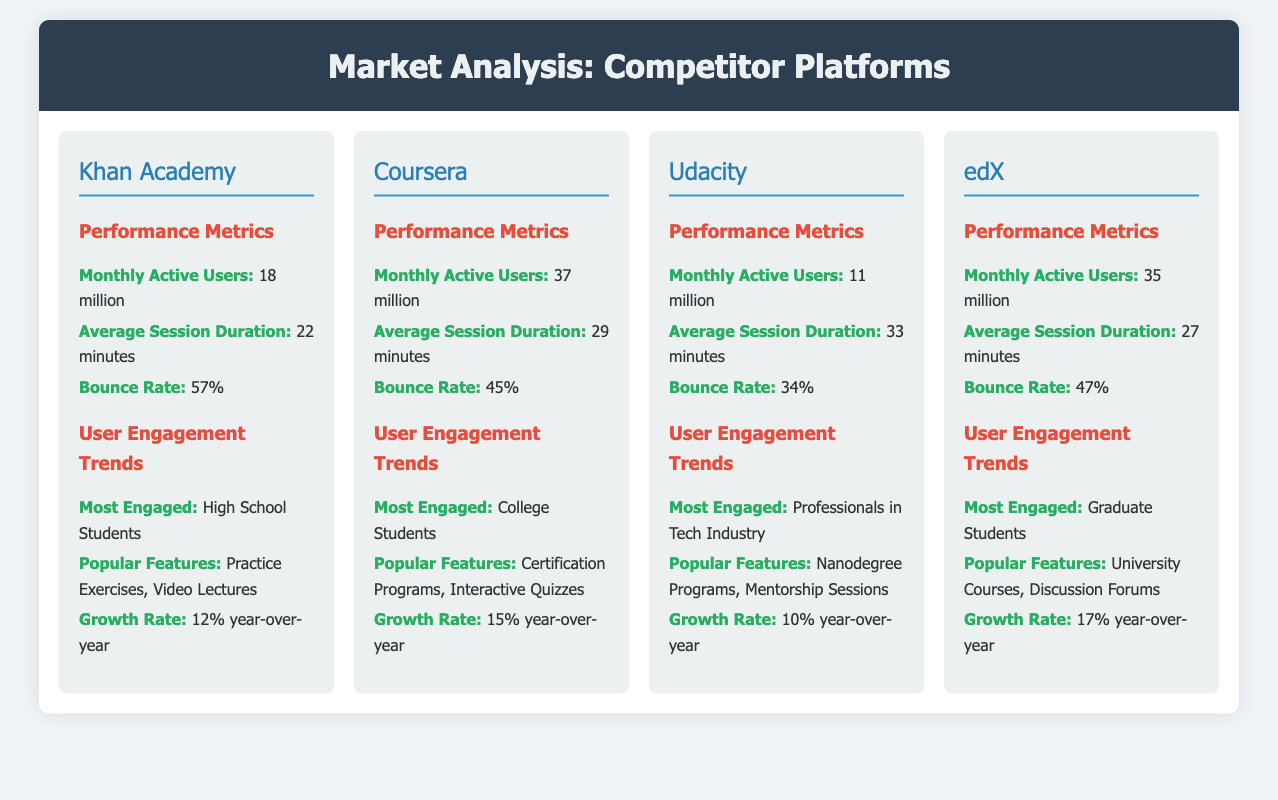What is the Monthly Active Users for Khan Academy? The Monthly Active Users for Khan Academy is directly stated in the document.
Answer: 18 million What is the Average Session Duration for Coursera? The Average Session Duration for Coursera is clearly listed in the performance metrics section of the document.
Answer: 29 minutes Which platform has the highest Monthly Active Users? A comparison of the Monthly Active Users shows that Coursera has the highest number among the platforms listed.
Answer: 37 million What is the Bounce Rate for Udacity? The Bounce Rate for Udacity is provided in the performance metrics section of the document.
Answer: 34% Among the platforms listed, which one has the highest Growth Rate? The Growth Rate for each platform is found by comparing the percentages provided, identifying the platform with the maximum value.
Answer: edX (17% year-over-year) What are the popular features for edX? The popular features for edX are listed under the User Engagement Trends section in the document.
Answer: University Courses, Discussion Forums Who are the most engaged users on Khan Academy? The most engaged group of users for Khan Academy is specified in the user engagement trends.
Answer: High School Students Which platform engages professionals in the tech industry the most? Referring to the user engagement trends, Udacity is noted for engaging this specific group.
Answer: Udacity What is the Bounce Rate for Coursera? The Bounce Rate for Coursera can be found in the performance metrics section.
Answer: 45% 